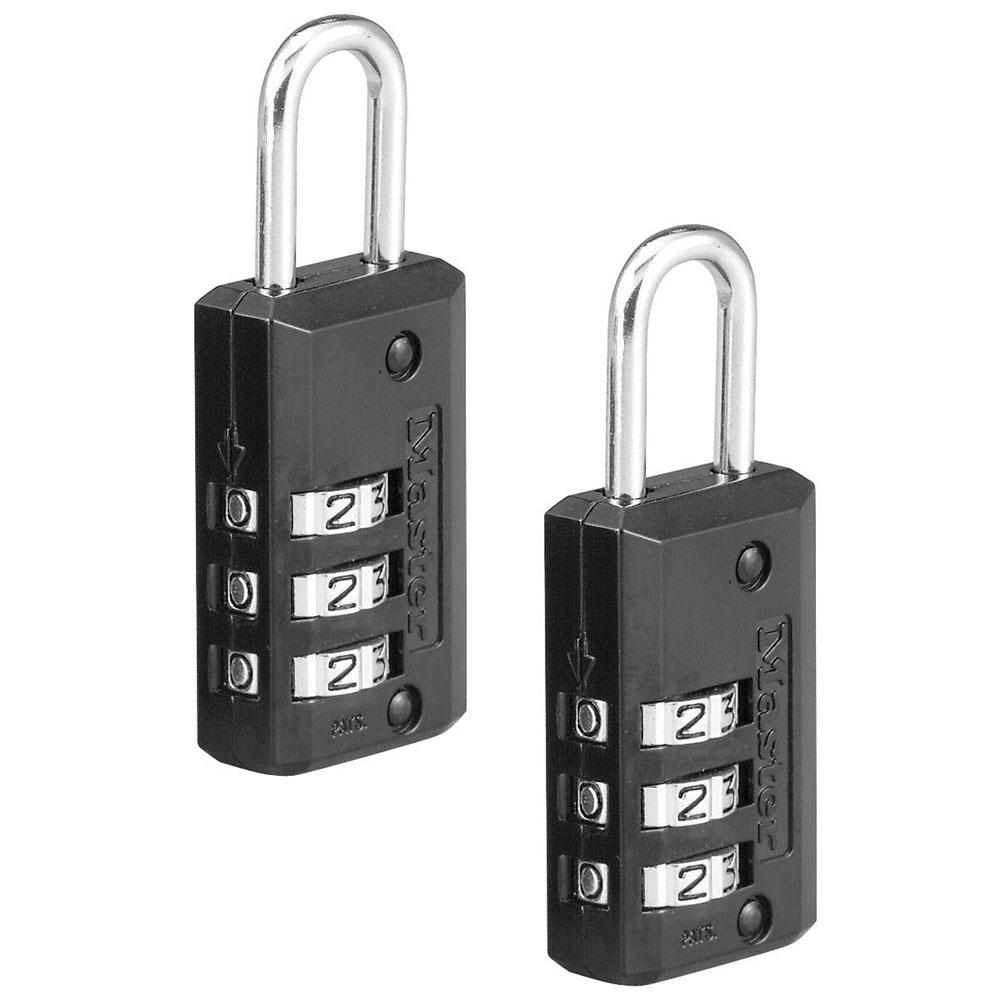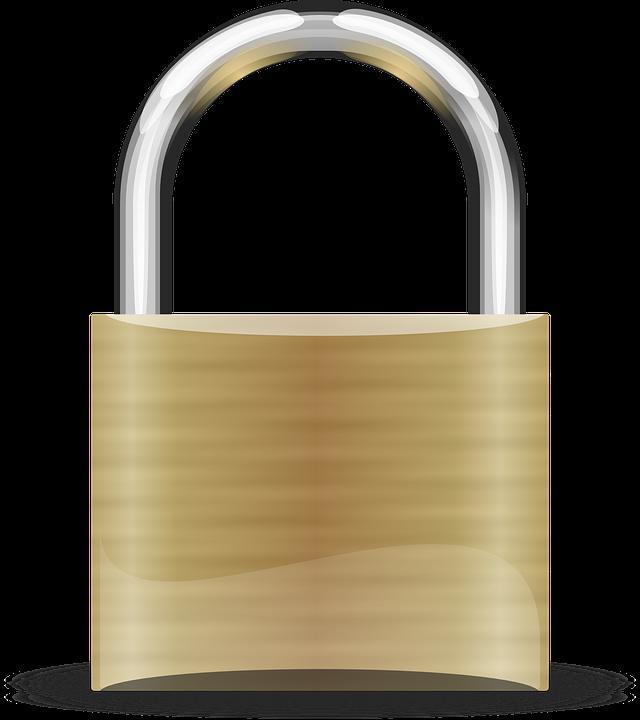The first image is the image on the left, the second image is the image on the right. For the images displayed, is the sentence "At least one of the locks has a black body with at least three rows of combination wheels on its front." factually correct? Answer yes or no. Yes. The first image is the image on the left, the second image is the image on the right. Assess this claim about the two images: "One or more locks have their rotating discs showing on the side, while another lock does not have them on the side.". Correct or not? Answer yes or no. Yes. 